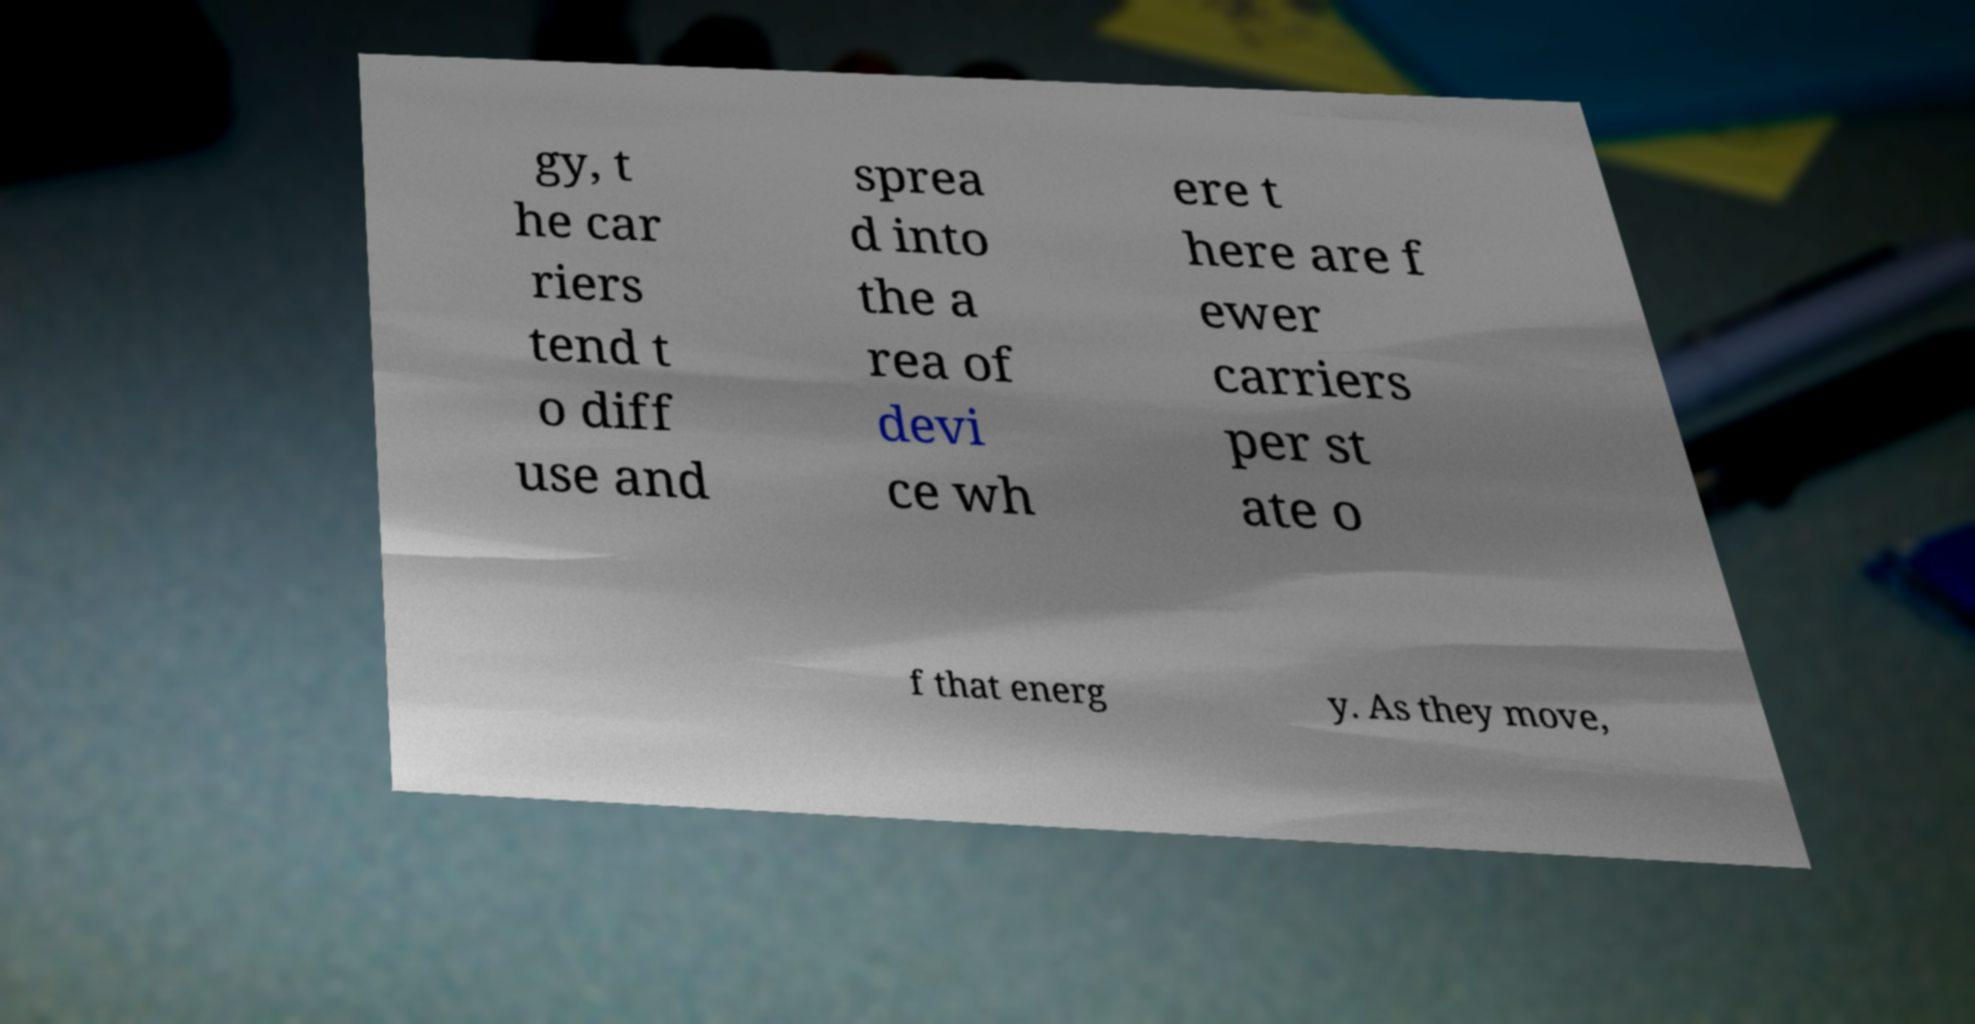What messages or text are displayed in this image? I need them in a readable, typed format. gy, t he car riers tend t o diff use and sprea d into the a rea of devi ce wh ere t here are f ewer carriers per st ate o f that energ y. As they move, 